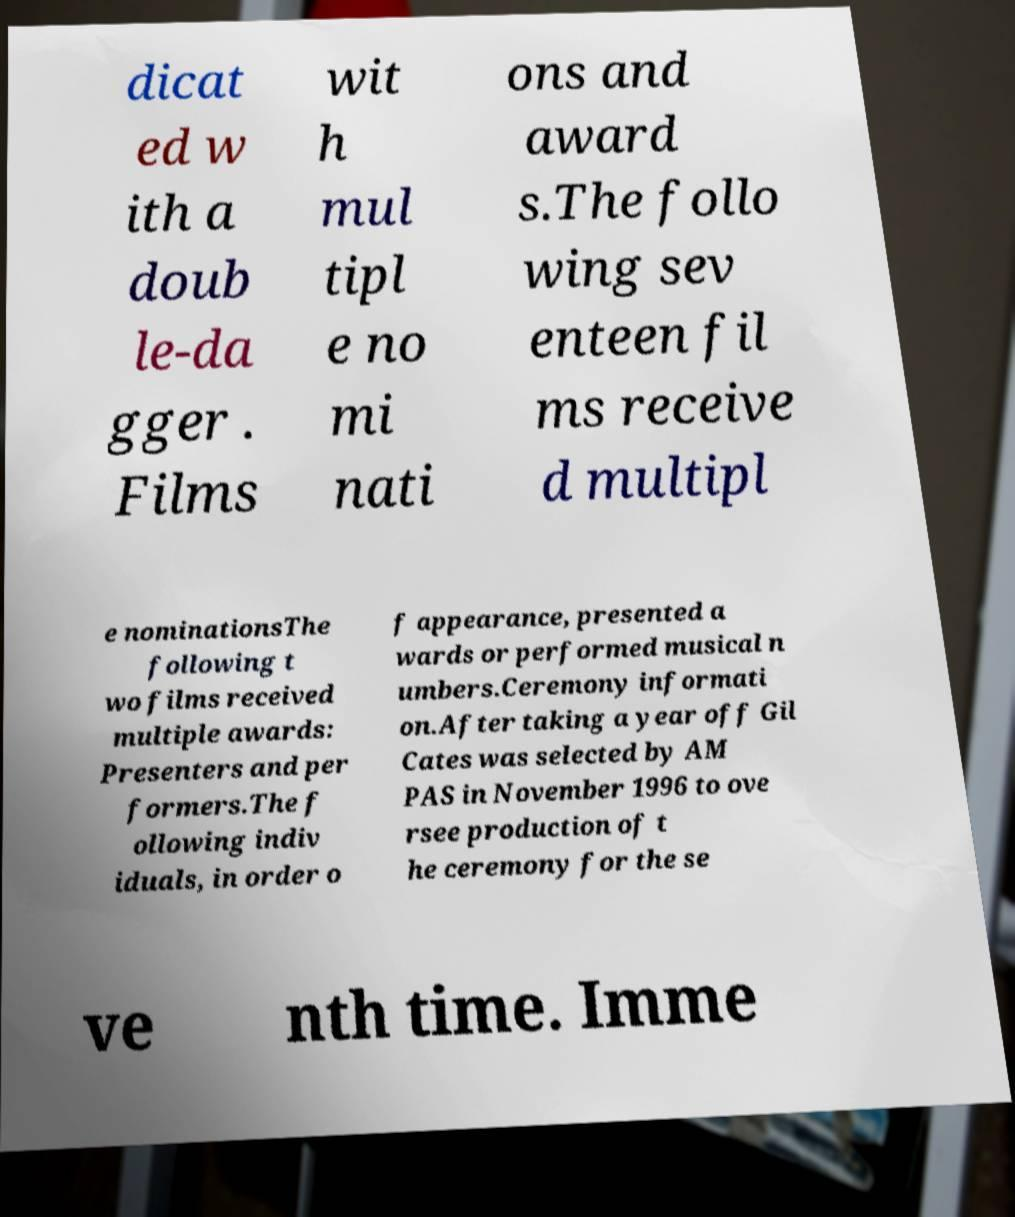Please read and relay the text visible in this image. What does it say? dicat ed w ith a doub le-da gger . Films wit h mul tipl e no mi nati ons and award s.The follo wing sev enteen fil ms receive d multipl e nominationsThe following t wo films received multiple awards: Presenters and per formers.The f ollowing indiv iduals, in order o f appearance, presented a wards or performed musical n umbers.Ceremony informati on.After taking a year off Gil Cates was selected by AM PAS in November 1996 to ove rsee production of t he ceremony for the se ve nth time. Imme 